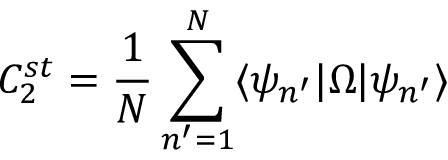Convert formula to latex. <formula><loc_0><loc_0><loc_500><loc_500>C _ { 2 } ^ { s t } = \frac { 1 } { N } \sum _ { n ^ { \prime } = 1 } ^ { N } \langle \psi _ { n ^ { \prime } } | \Omega | \psi _ { n ^ { \prime } } \rangle</formula> 